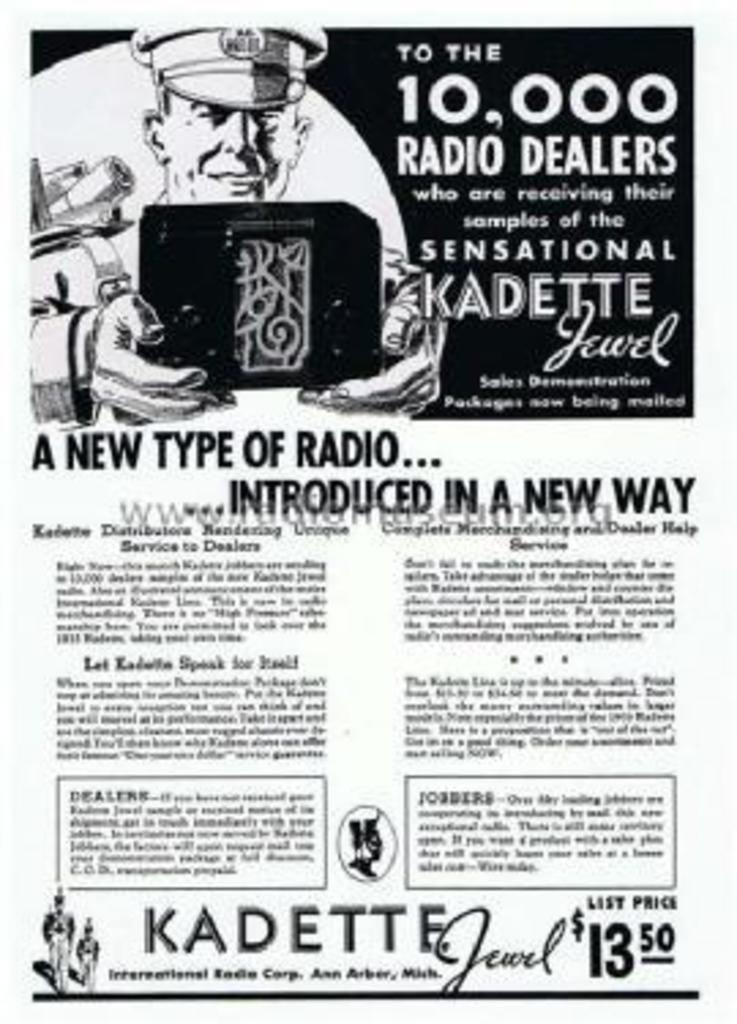Provide a one-sentence caption for the provided image. 10000 radio dealer will receive a sample of the radio. 